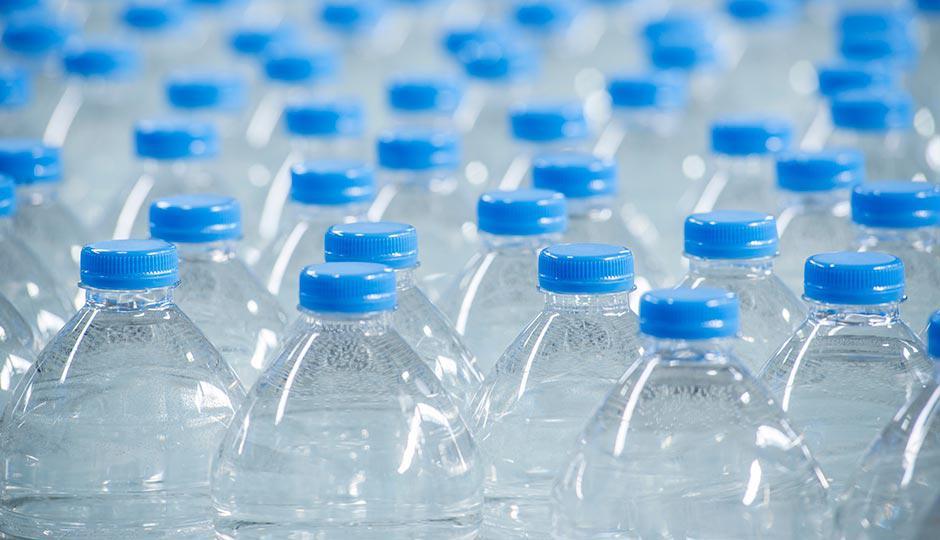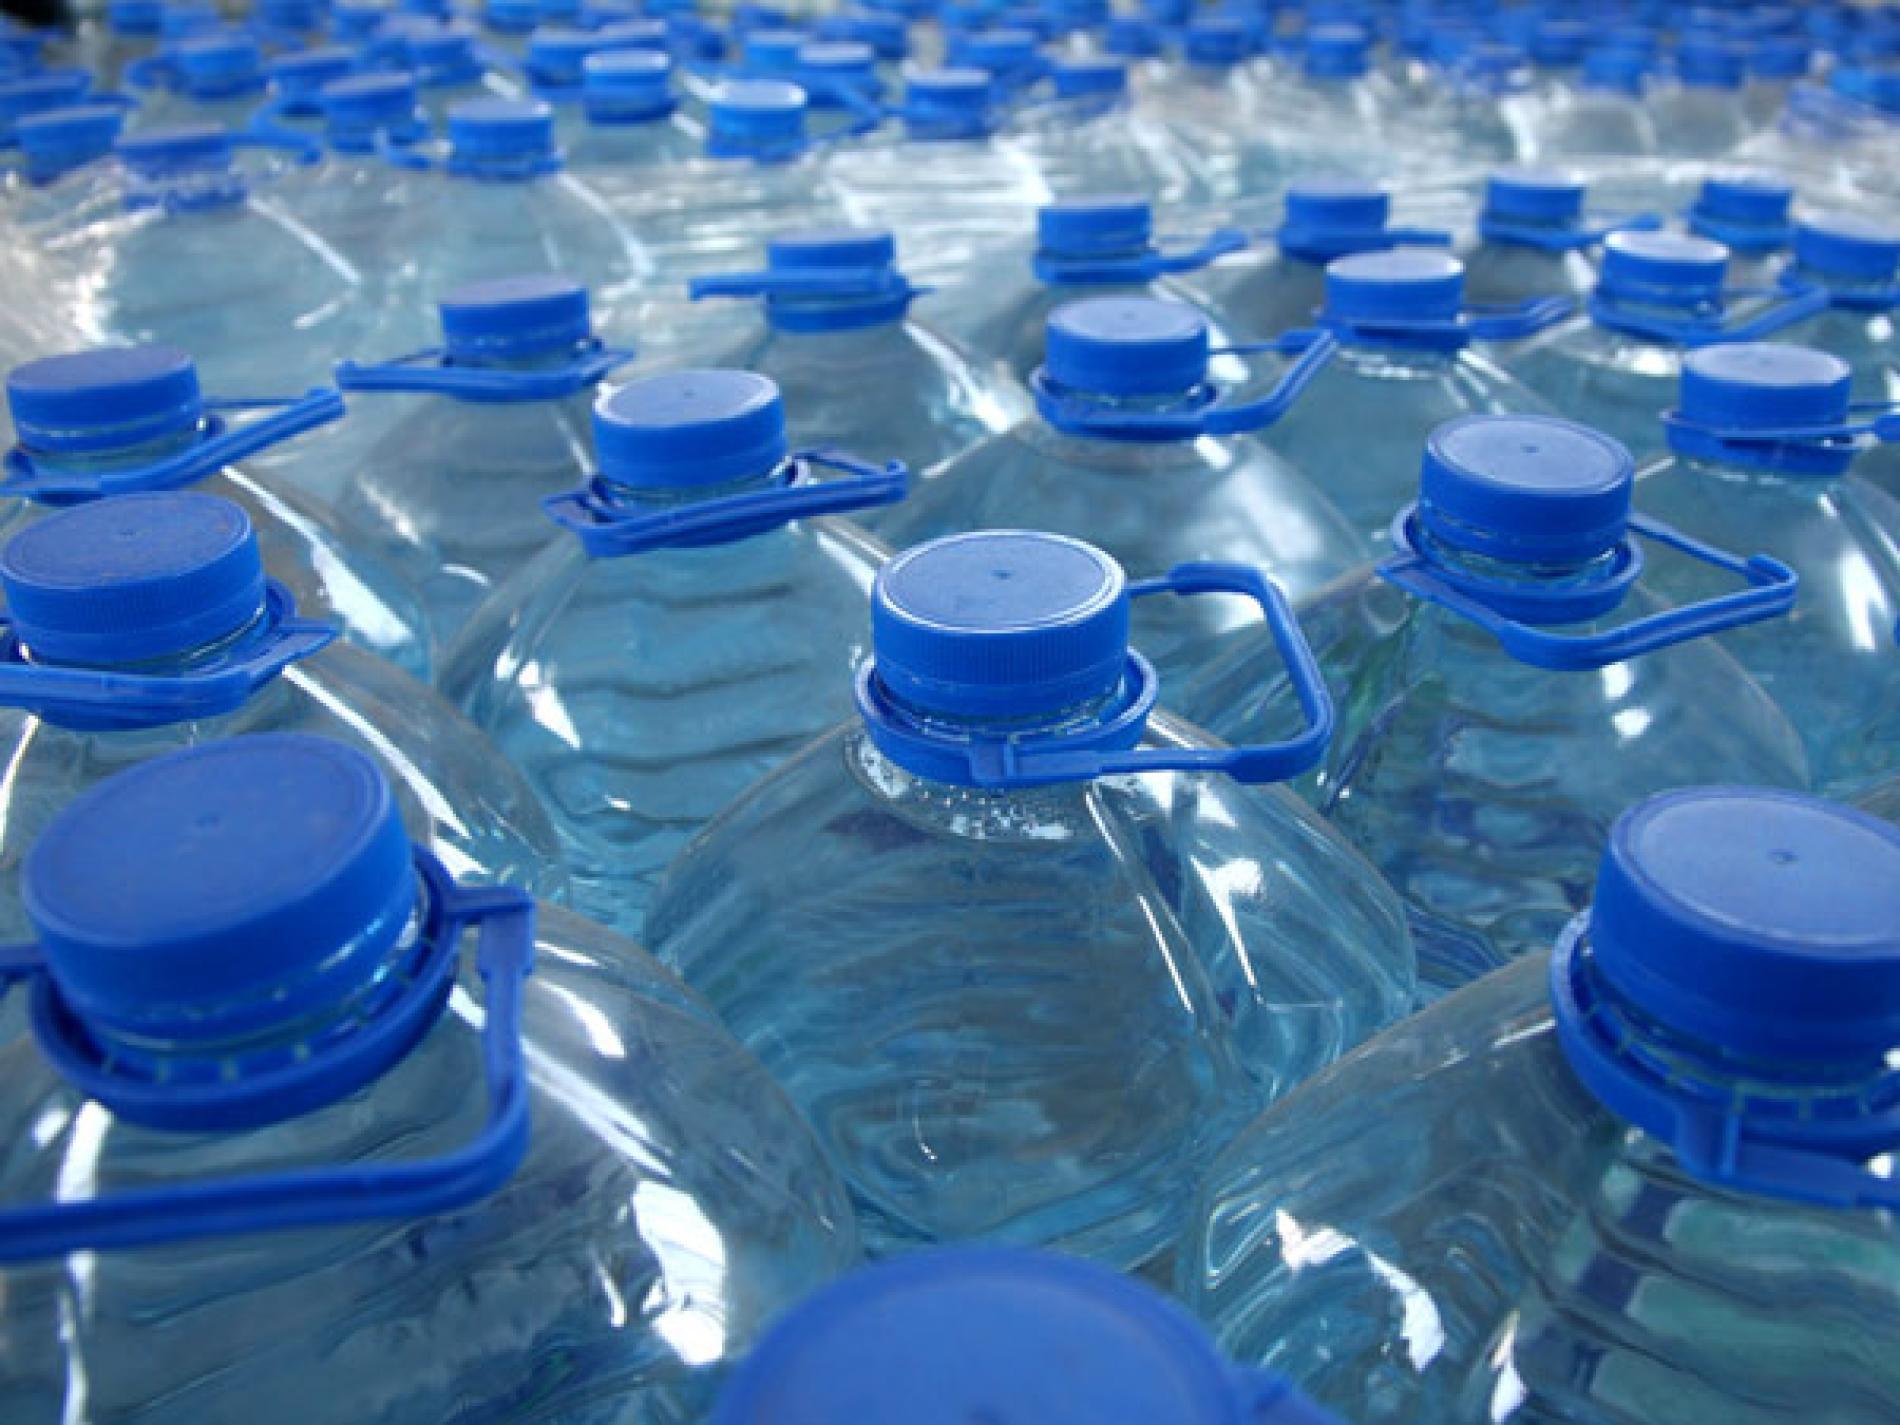The first image is the image on the left, the second image is the image on the right. For the images shown, is this caption "the bottles in the image on the right have white caps." true? Answer yes or no. No. The first image is the image on the left, the second image is the image on the right. Given the left and right images, does the statement "The bottles have white caps in at least one of the images." hold true? Answer yes or no. No. 